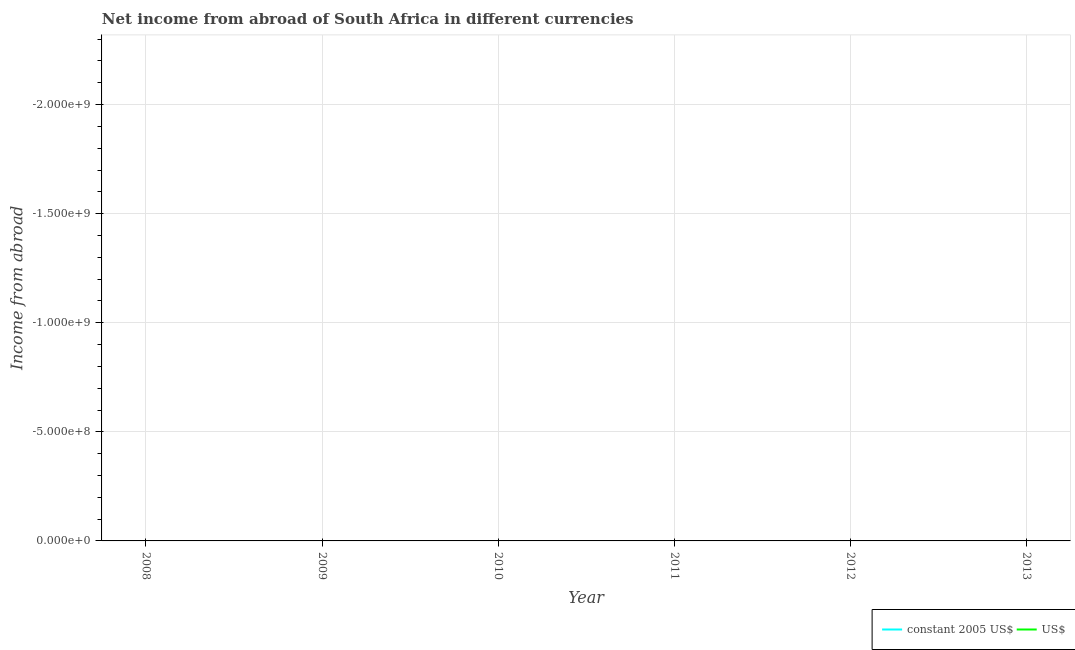How many different coloured lines are there?
Offer a terse response. 0. Is the number of lines equal to the number of legend labels?
Your response must be concise. No. Across all years, what is the minimum income from abroad in constant 2005 us$?
Keep it short and to the point. 0. What is the total income from abroad in us$ in the graph?
Your answer should be very brief. 0. Does the income from abroad in us$ monotonically increase over the years?
Provide a short and direct response. No. Is the income from abroad in us$ strictly greater than the income from abroad in constant 2005 us$ over the years?
Keep it short and to the point. Yes. Is the income from abroad in constant 2005 us$ strictly less than the income from abroad in us$ over the years?
Keep it short and to the point. Yes. How many lines are there?
Make the answer very short. 0. How many years are there in the graph?
Your answer should be very brief. 6. What is the difference between two consecutive major ticks on the Y-axis?
Your answer should be compact. 5.00e+08. Does the graph contain any zero values?
Your answer should be compact. Yes. Does the graph contain grids?
Your answer should be compact. Yes. How are the legend labels stacked?
Keep it short and to the point. Horizontal. What is the title of the graph?
Provide a succinct answer. Net income from abroad of South Africa in different currencies. Does "GDP at market prices" appear as one of the legend labels in the graph?
Make the answer very short. No. What is the label or title of the X-axis?
Make the answer very short. Year. What is the label or title of the Y-axis?
Provide a short and direct response. Income from abroad. What is the Income from abroad in constant 2005 US$ in 2009?
Keep it short and to the point. 0. What is the Income from abroad in US$ in 2009?
Ensure brevity in your answer.  0. What is the Income from abroad of constant 2005 US$ in 2012?
Your answer should be very brief. 0. What is the Income from abroad in constant 2005 US$ in 2013?
Ensure brevity in your answer.  0. 